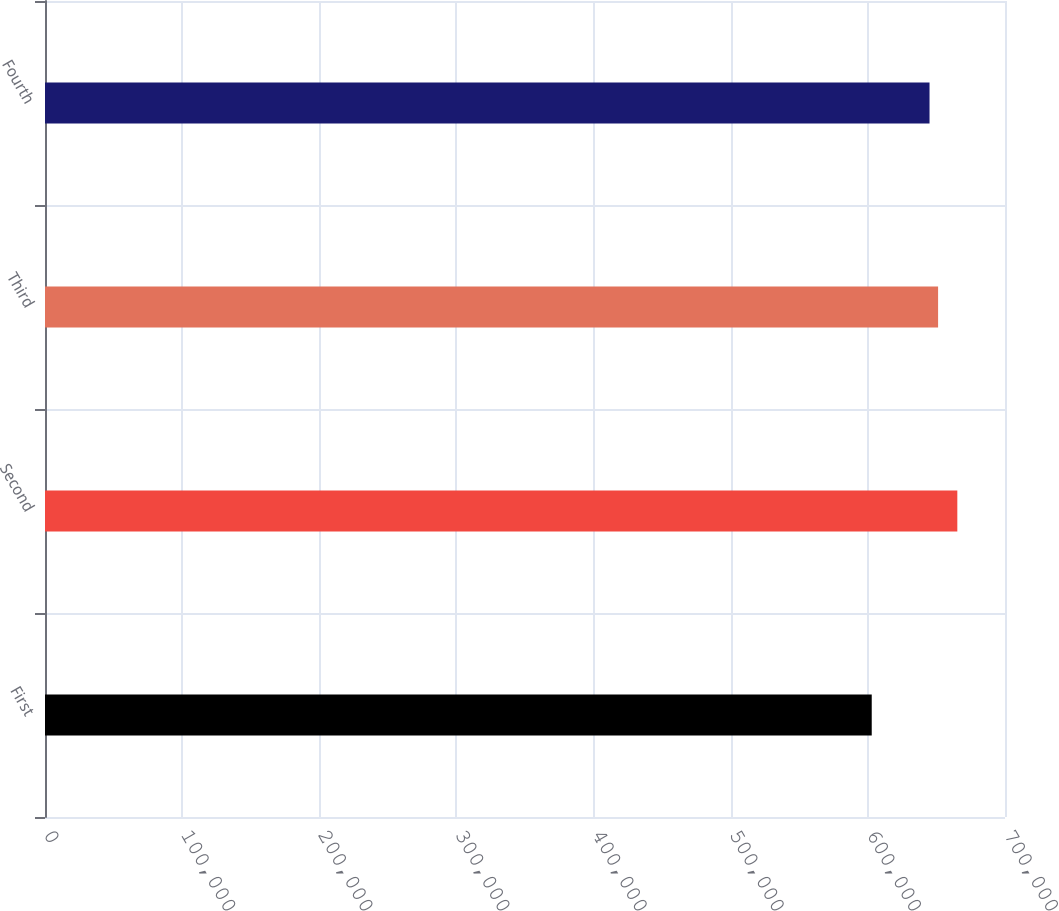Convert chart. <chart><loc_0><loc_0><loc_500><loc_500><bar_chart><fcel>First<fcel>Second<fcel>Third<fcel>Fourth<nl><fcel>602828<fcel>665236<fcel>651213<fcel>644972<nl></chart> 